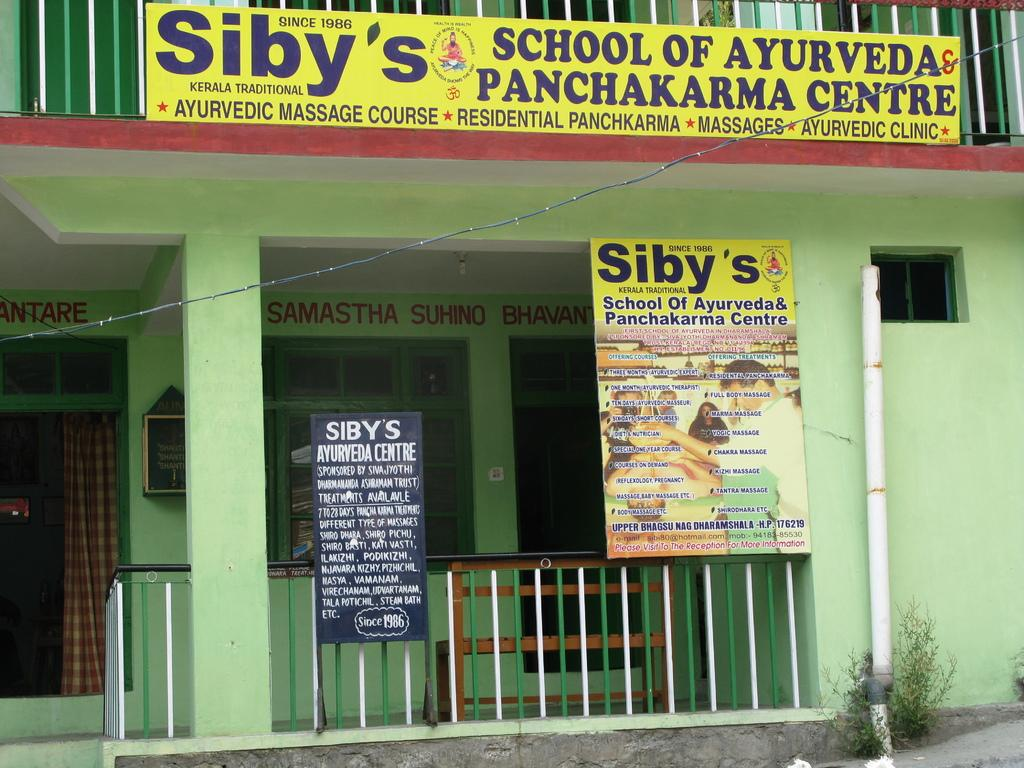What type of structure can be seen in the image? There is a building in the image. What are some features of the building? There are boards, railings, windows, a curtain, a wall, a pillar, and a pipe visible in the image. Are there any other objects or elements in the image? Yes, there are plants, frames, and a bench present in the image. Is there any text or writing in the image? Yes, something is written on the wall in the image. What is the current grade of the student in the image? There is no student or grade present in the image; it features a building with various features and objects. 